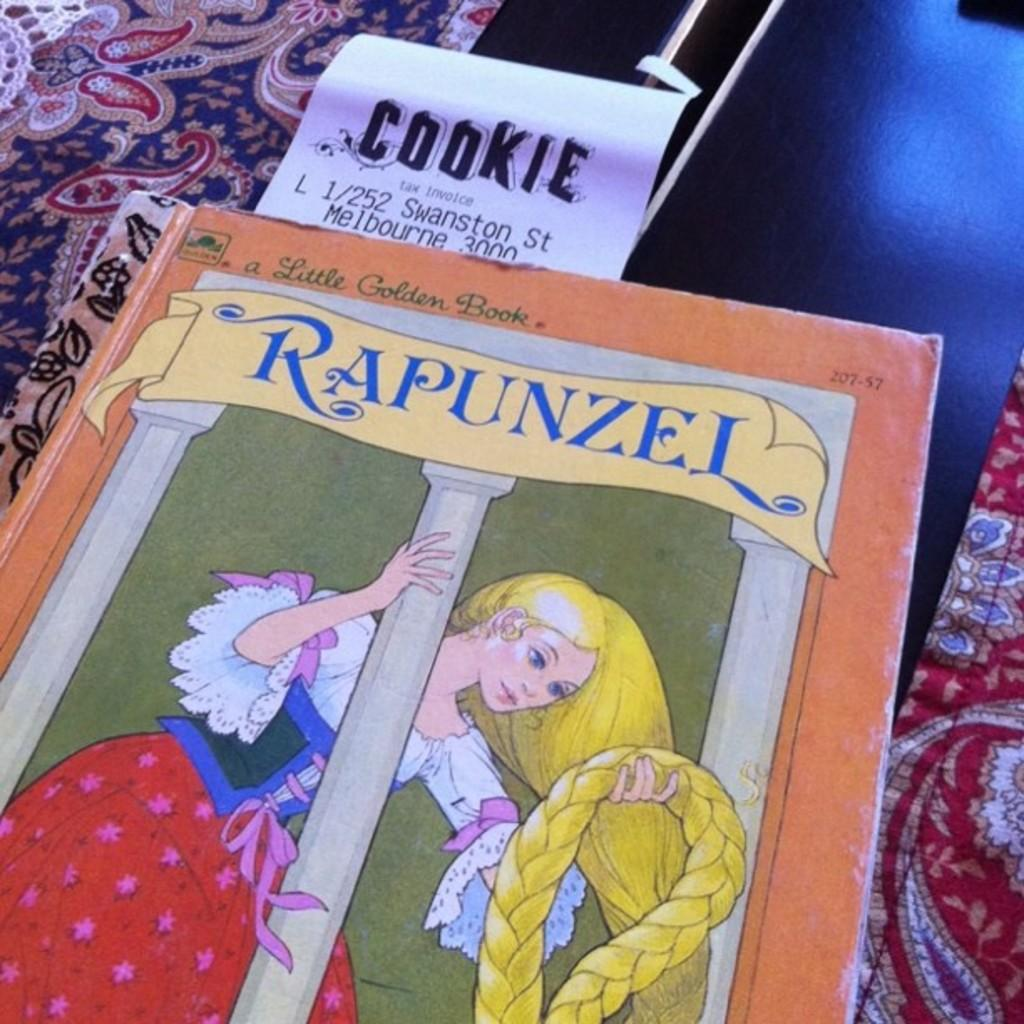<image>
Give a short and clear explanation of the subsequent image. A Little Golden Book titled Rapunzel with a receipt that states Cookie 